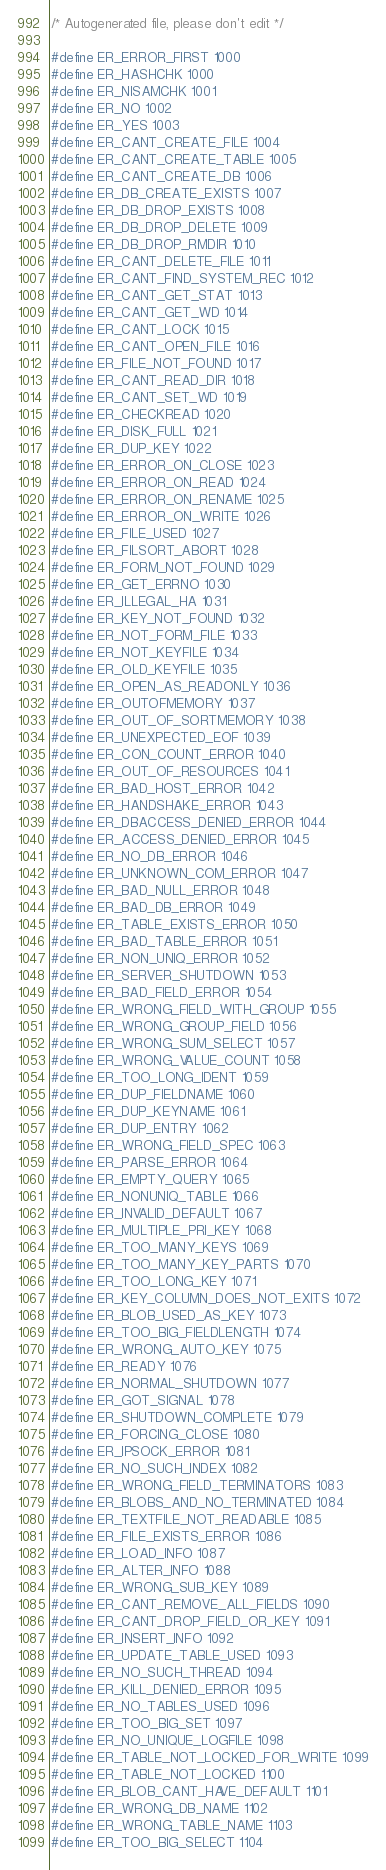Convert code to text. <code><loc_0><loc_0><loc_500><loc_500><_C_>/* Autogenerated file, please don't edit */

#define ER_ERROR_FIRST 1000
#define ER_HASHCHK 1000
#define ER_NISAMCHK 1001
#define ER_NO 1002
#define ER_YES 1003
#define ER_CANT_CREATE_FILE 1004
#define ER_CANT_CREATE_TABLE 1005
#define ER_CANT_CREATE_DB 1006
#define ER_DB_CREATE_EXISTS 1007
#define ER_DB_DROP_EXISTS 1008
#define ER_DB_DROP_DELETE 1009
#define ER_DB_DROP_RMDIR 1010
#define ER_CANT_DELETE_FILE 1011
#define ER_CANT_FIND_SYSTEM_REC 1012
#define ER_CANT_GET_STAT 1013
#define ER_CANT_GET_WD 1014
#define ER_CANT_LOCK 1015
#define ER_CANT_OPEN_FILE 1016
#define ER_FILE_NOT_FOUND 1017
#define ER_CANT_READ_DIR 1018
#define ER_CANT_SET_WD 1019
#define ER_CHECKREAD 1020
#define ER_DISK_FULL 1021
#define ER_DUP_KEY 1022
#define ER_ERROR_ON_CLOSE 1023
#define ER_ERROR_ON_READ 1024
#define ER_ERROR_ON_RENAME 1025
#define ER_ERROR_ON_WRITE 1026
#define ER_FILE_USED 1027
#define ER_FILSORT_ABORT 1028
#define ER_FORM_NOT_FOUND 1029
#define ER_GET_ERRNO 1030
#define ER_ILLEGAL_HA 1031
#define ER_KEY_NOT_FOUND 1032
#define ER_NOT_FORM_FILE 1033
#define ER_NOT_KEYFILE 1034
#define ER_OLD_KEYFILE 1035
#define ER_OPEN_AS_READONLY 1036
#define ER_OUTOFMEMORY 1037
#define ER_OUT_OF_SORTMEMORY 1038
#define ER_UNEXPECTED_EOF 1039
#define ER_CON_COUNT_ERROR 1040
#define ER_OUT_OF_RESOURCES 1041
#define ER_BAD_HOST_ERROR 1042
#define ER_HANDSHAKE_ERROR 1043
#define ER_DBACCESS_DENIED_ERROR 1044
#define ER_ACCESS_DENIED_ERROR 1045
#define ER_NO_DB_ERROR 1046
#define ER_UNKNOWN_COM_ERROR 1047
#define ER_BAD_NULL_ERROR 1048
#define ER_BAD_DB_ERROR 1049
#define ER_TABLE_EXISTS_ERROR 1050
#define ER_BAD_TABLE_ERROR 1051
#define ER_NON_UNIQ_ERROR 1052
#define ER_SERVER_SHUTDOWN 1053
#define ER_BAD_FIELD_ERROR 1054
#define ER_WRONG_FIELD_WITH_GROUP 1055
#define ER_WRONG_GROUP_FIELD 1056
#define ER_WRONG_SUM_SELECT 1057
#define ER_WRONG_VALUE_COUNT 1058
#define ER_TOO_LONG_IDENT 1059
#define ER_DUP_FIELDNAME 1060
#define ER_DUP_KEYNAME 1061
#define ER_DUP_ENTRY 1062
#define ER_WRONG_FIELD_SPEC 1063
#define ER_PARSE_ERROR 1064
#define ER_EMPTY_QUERY 1065
#define ER_NONUNIQ_TABLE 1066
#define ER_INVALID_DEFAULT 1067
#define ER_MULTIPLE_PRI_KEY 1068
#define ER_TOO_MANY_KEYS 1069
#define ER_TOO_MANY_KEY_PARTS 1070
#define ER_TOO_LONG_KEY 1071
#define ER_KEY_COLUMN_DOES_NOT_EXITS 1072
#define ER_BLOB_USED_AS_KEY 1073
#define ER_TOO_BIG_FIELDLENGTH 1074
#define ER_WRONG_AUTO_KEY 1075
#define ER_READY 1076
#define ER_NORMAL_SHUTDOWN 1077
#define ER_GOT_SIGNAL 1078
#define ER_SHUTDOWN_COMPLETE 1079
#define ER_FORCING_CLOSE 1080
#define ER_IPSOCK_ERROR 1081
#define ER_NO_SUCH_INDEX 1082
#define ER_WRONG_FIELD_TERMINATORS 1083
#define ER_BLOBS_AND_NO_TERMINATED 1084
#define ER_TEXTFILE_NOT_READABLE 1085
#define ER_FILE_EXISTS_ERROR 1086
#define ER_LOAD_INFO 1087
#define ER_ALTER_INFO 1088
#define ER_WRONG_SUB_KEY 1089
#define ER_CANT_REMOVE_ALL_FIELDS 1090
#define ER_CANT_DROP_FIELD_OR_KEY 1091
#define ER_INSERT_INFO 1092
#define ER_UPDATE_TABLE_USED 1093
#define ER_NO_SUCH_THREAD 1094
#define ER_KILL_DENIED_ERROR 1095
#define ER_NO_TABLES_USED 1096
#define ER_TOO_BIG_SET 1097
#define ER_NO_UNIQUE_LOGFILE 1098
#define ER_TABLE_NOT_LOCKED_FOR_WRITE 1099
#define ER_TABLE_NOT_LOCKED 1100
#define ER_BLOB_CANT_HAVE_DEFAULT 1101
#define ER_WRONG_DB_NAME 1102
#define ER_WRONG_TABLE_NAME 1103
#define ER_TOO_BIG_SELECT 1104</code> 